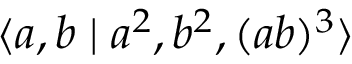Convert formula to latex. <formula><loc_0><loc_0><loc_500><loc_500>\langle a , b | a ^ { 2 } , b ^ { 2 } , ( a b ) ^ { 3 } \rangle</formula> 